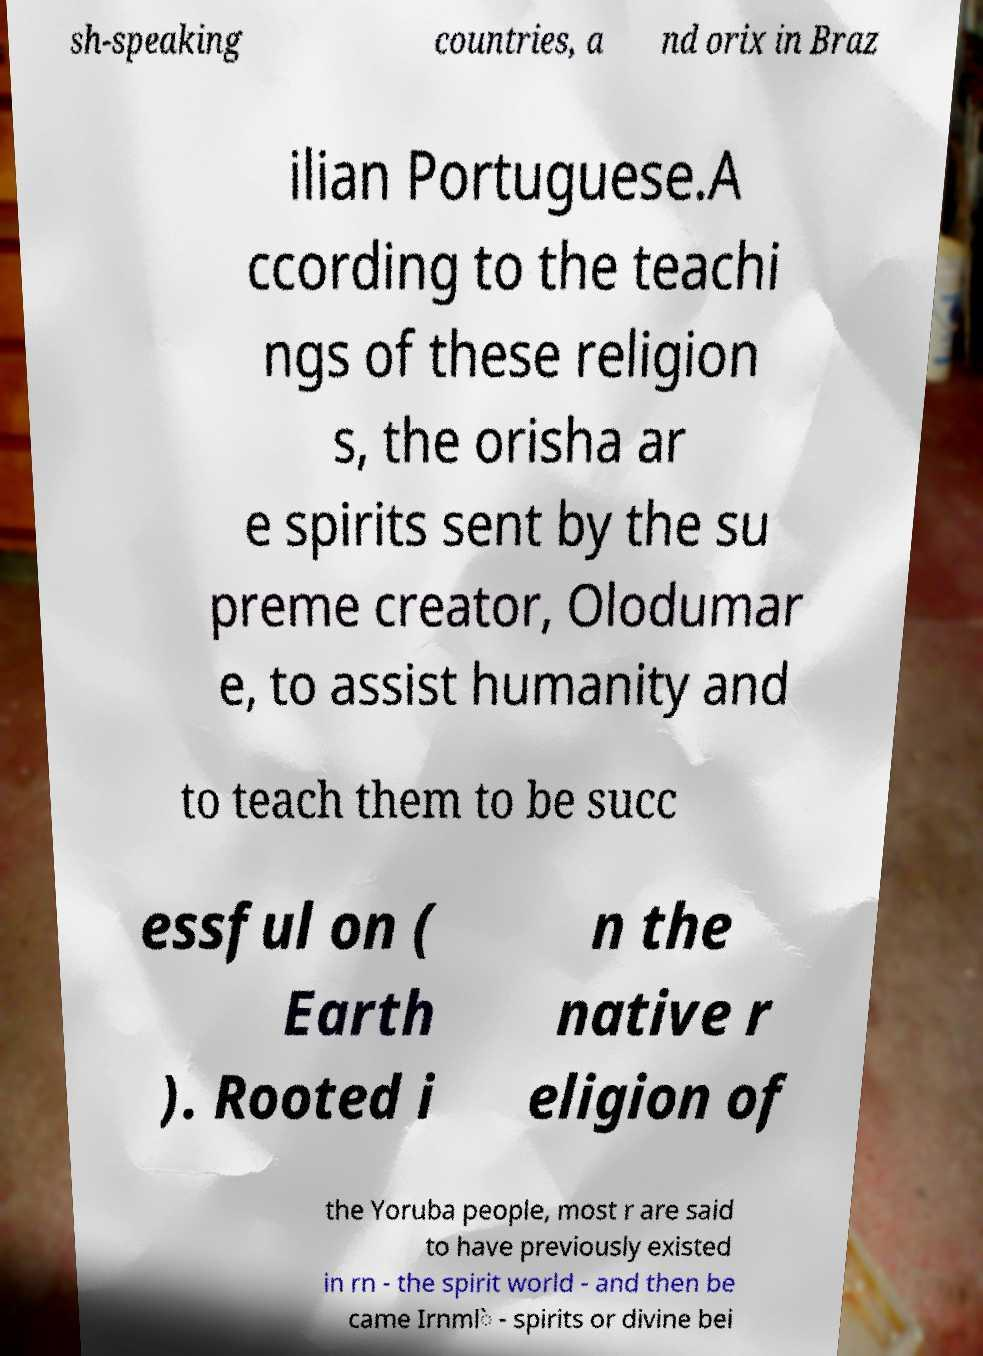Please identify and transcribe the text found in this image. sh-speaking countries, a nd orix in Braz ilian Portuguese.A ccording to the teachi ngs of these religion s, the orisha ar e spirits sent by the su preme creator, Olodumar e, to assist humanity and to teach them to be succ essful on ( Earth ). Rooted i n the native r eligion of the Yoruba people, most r are said to have previously existed in rn - the spirit world - and then be came Irnml̀ - spirits or divine bei 